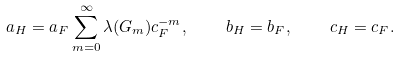Convert formula to latex. <formula><loc_0><loc_0><loc_500><loc_500>a _ { H } = a _ { F } \sum _ { m = 0 } ^ { \infty } \lambda ( G _ { m } ) c _ { F } ^ { - m } , \quad b _ { H } = b _ { F } , \quad c _ { H } = c _ { F } .</formula> 